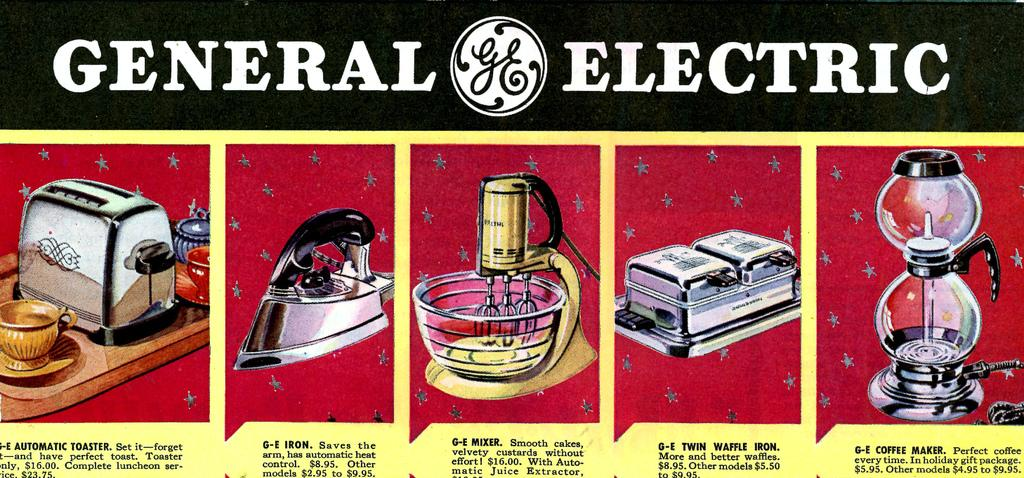<image>
Offer a succinct explanation of the picture presented. Genreal elecric ad sign trying to sell kitchen appliances 